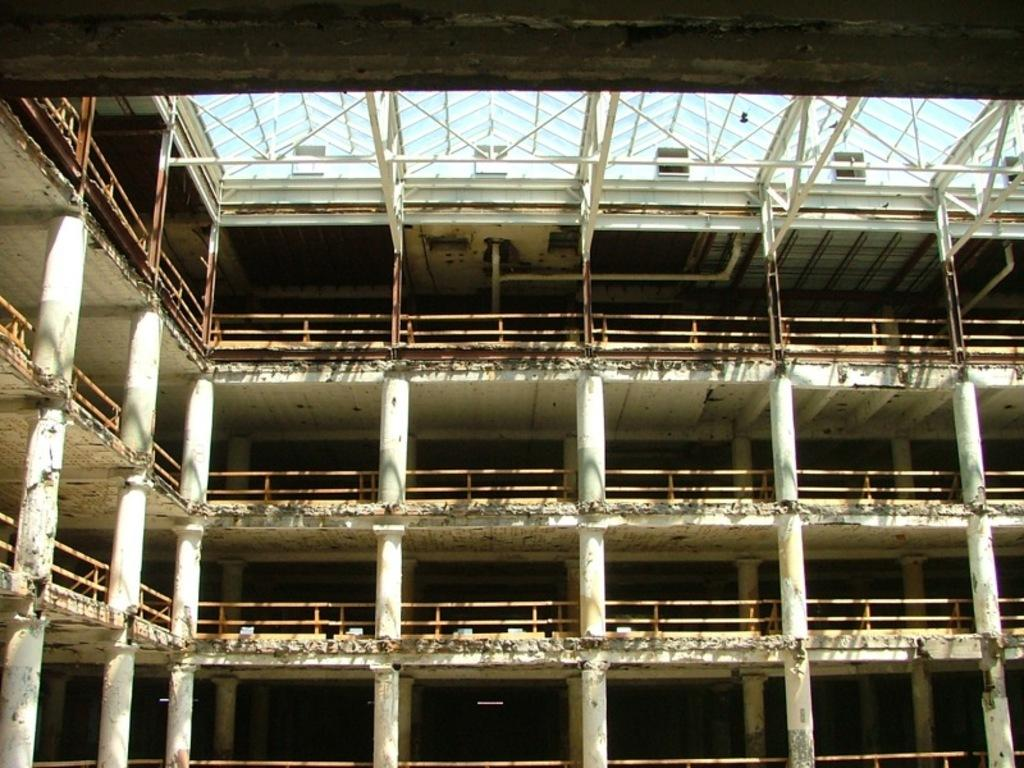What is the main structure in the foreground of the image? There is a building in the foreground of the image. What architectural features can be seen on the building? The building has pillars and a railing. What type of ceiling is present on the building? The building has a glass ceiling on the top. What type of quill is used to write on the glass ceiling in the image? There is no quill or writing present on the glass ceiling in the image. How does the tongue of the building affect its appearance in the image? The building does not have a tongue, so this aspect does not affect its appearance in the image. 